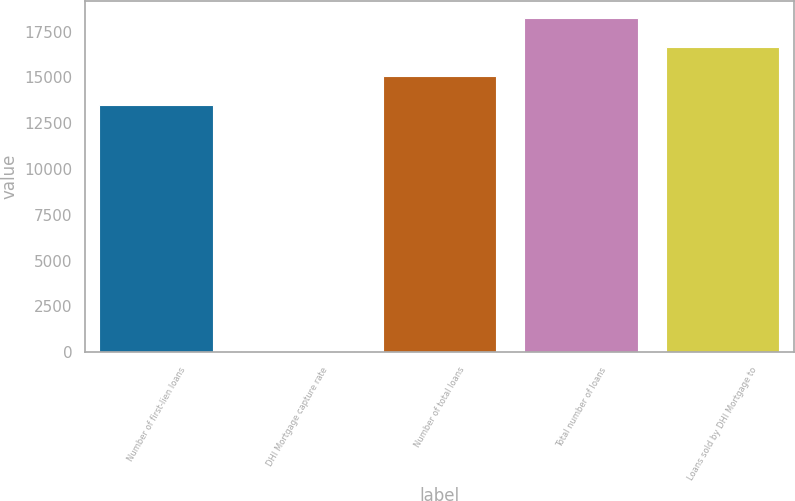Convert chart. <chart><loc_0><loc_0><loc_500><loc_500><bar_chart><fcel>Number of first-lien loans<fcel>DHI Mortgage capture rate<fcel>Number of total loans<fcel>Total number of loans<fcel>Loans sold by DHI Mortgage to<nl><fcel>13514<fcel>56<fcel>15089<fcel>18239<fcel>16664<nl></chart> 